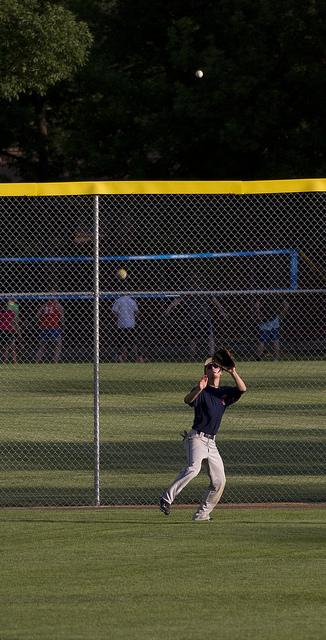What position is this player playing? outfield 